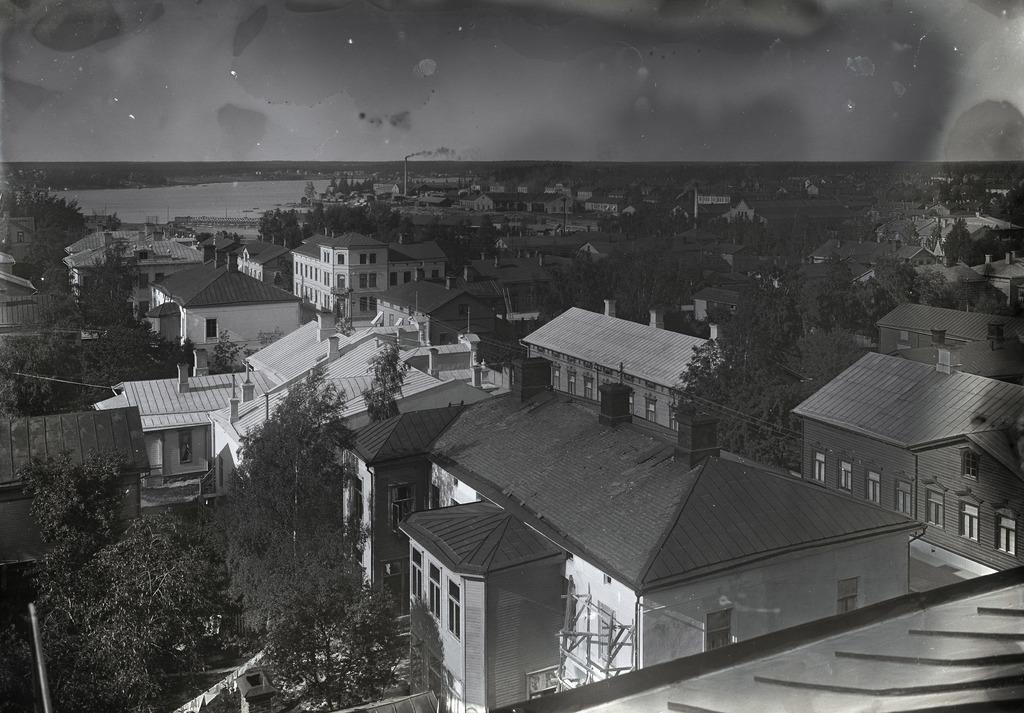What type of structures can be seen in the image? There are buildings in the image. What architectural features are visible on the buildings? There are windows visible on the buildings. What natural elements are present in the image? There are trees and water in the image. What man-made elements can be seen in the image? There are wires and a pole in the image. What is the color scheme of the image? The image is in black and white. What type of error can be seen in the image? There is no error present in the image; it is a clear representation of the scene. How many cattle are visible in the image? There are no cattle present in the image. 